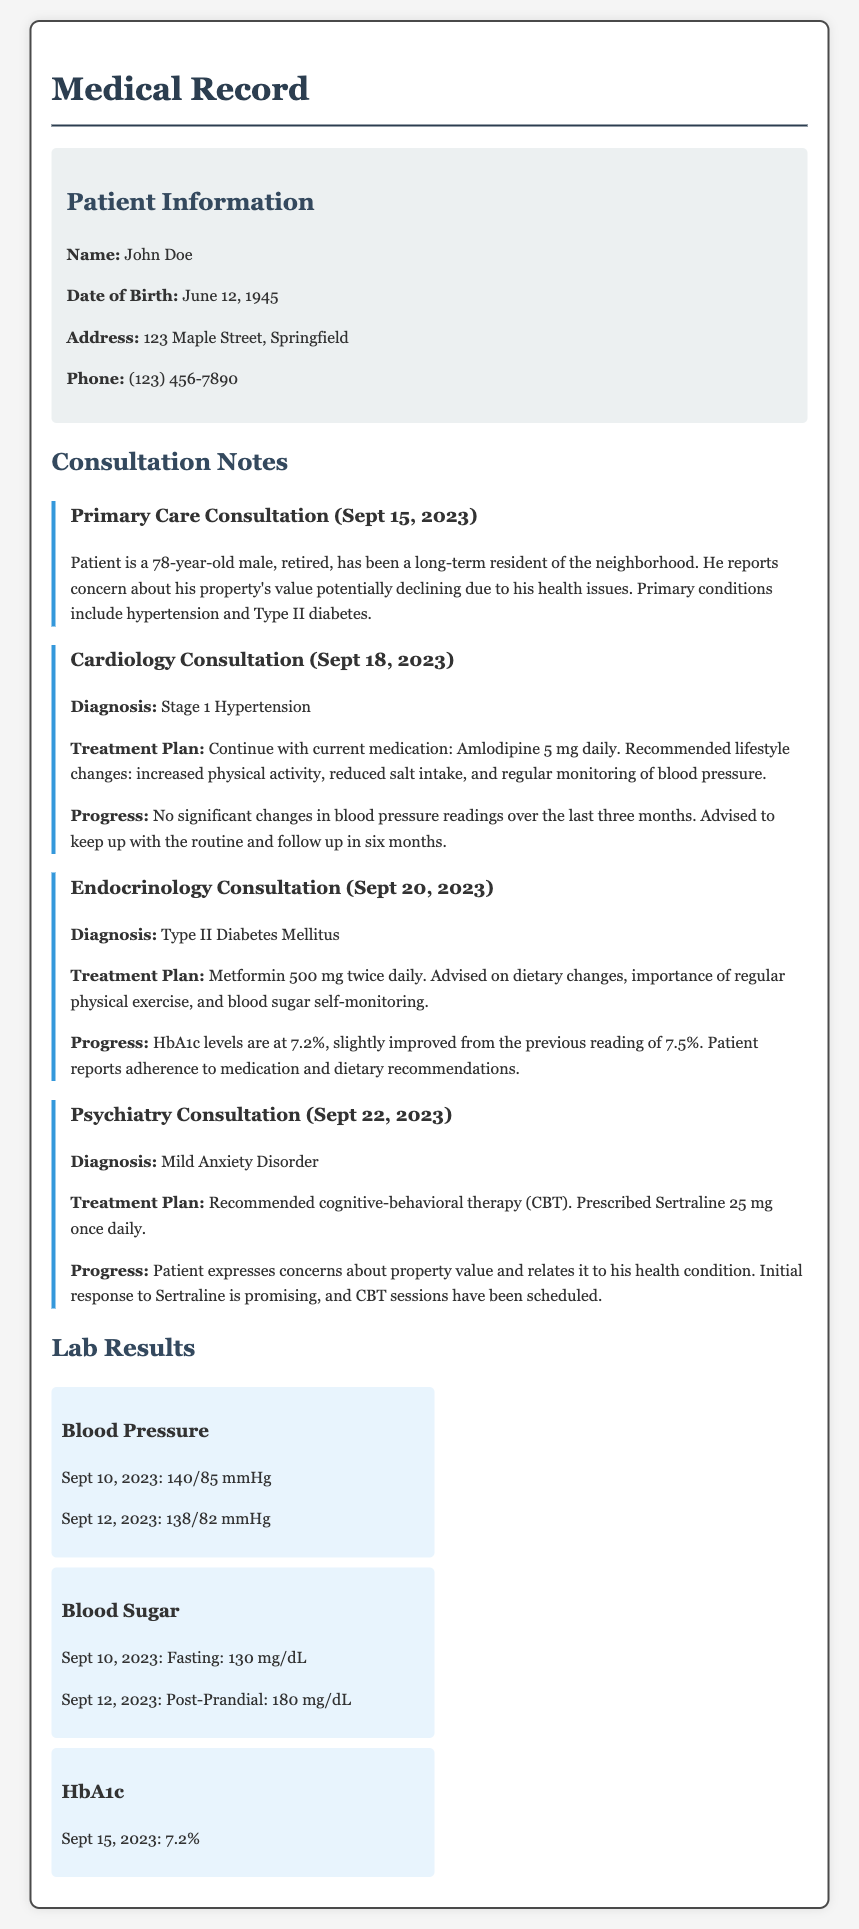What is the name of the patient? The name of the patient is mentioned in the patient information section.
Answer: John Doe What is the birth date of the patient? The birth date is provided in the patient information section.
Answer: June 12, 1945 What is the diagnosis from the Cardiology Consultation? This diagnosis can be found in the cardiology consultation section of the document.
Answer: Stage 1 Hypertension What medication is prescribed for Type II Diabetes? The treatment plan for diabetes includes specific medication mentioned in the endocrinology consultation.
Answer: Metformin 500 mg twice daily What is the patient's HbA1c level as of September 15, 2023? The HbA1c level can be retrieved from the lab results section dated September 15, 2023.
Answer: 7.2% What lifestyle changes were recommended for hypertension? The lifestyle changes are indicated in the cardiology consultation notes, which discuss recommendations for managing blood pressure.
Answer: Increased physical activity, reduced salt intake What therapy is recommended for Mild Anxiety Disorder? This information is noted in the psychiatry consultation section, which provides details about the treatment plan.
Answer: Cognitive-behavioral therapy (CBT) When is the follow-up for the cardiology consultation scheduled? The follow-up interval is mentioned in the treatment plan of the cardiology consult’s progress.
Answer: In six months Which two primary health conditions does the patient have? The primary health conditions are outlined in the primary care consultation notes.
Answer: Hypertension and Type II diabetes 